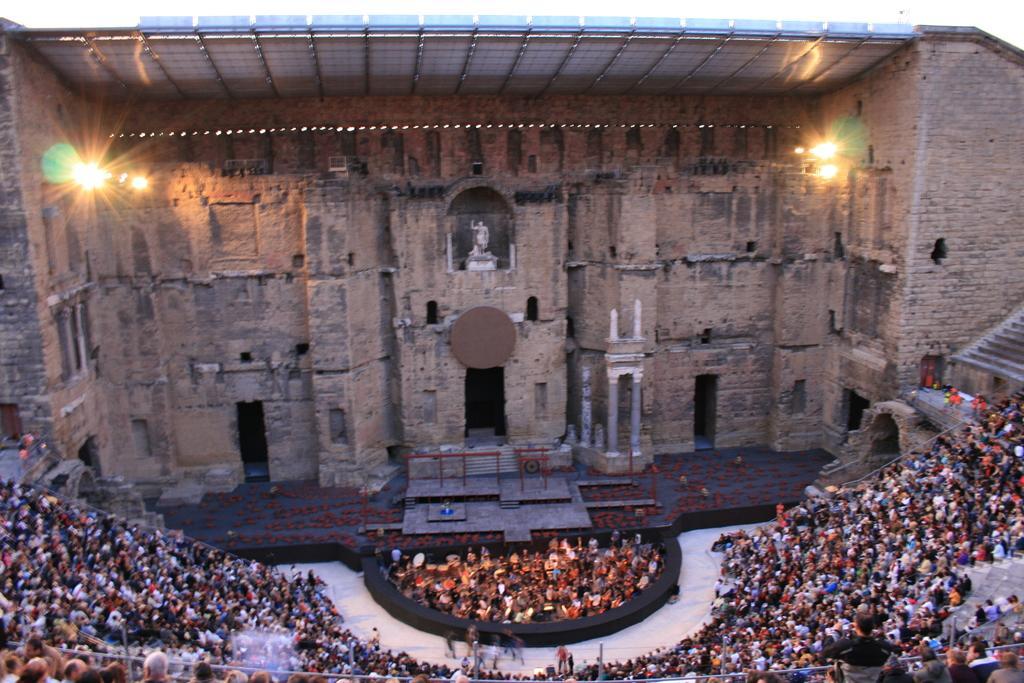Describe this image in one or two sentences. In this picture we can see the monument. At the bottom we can see the audience sitting on the chair. At the top there is a shed. Beside that we can see the lights. in the top right there is a sky. 